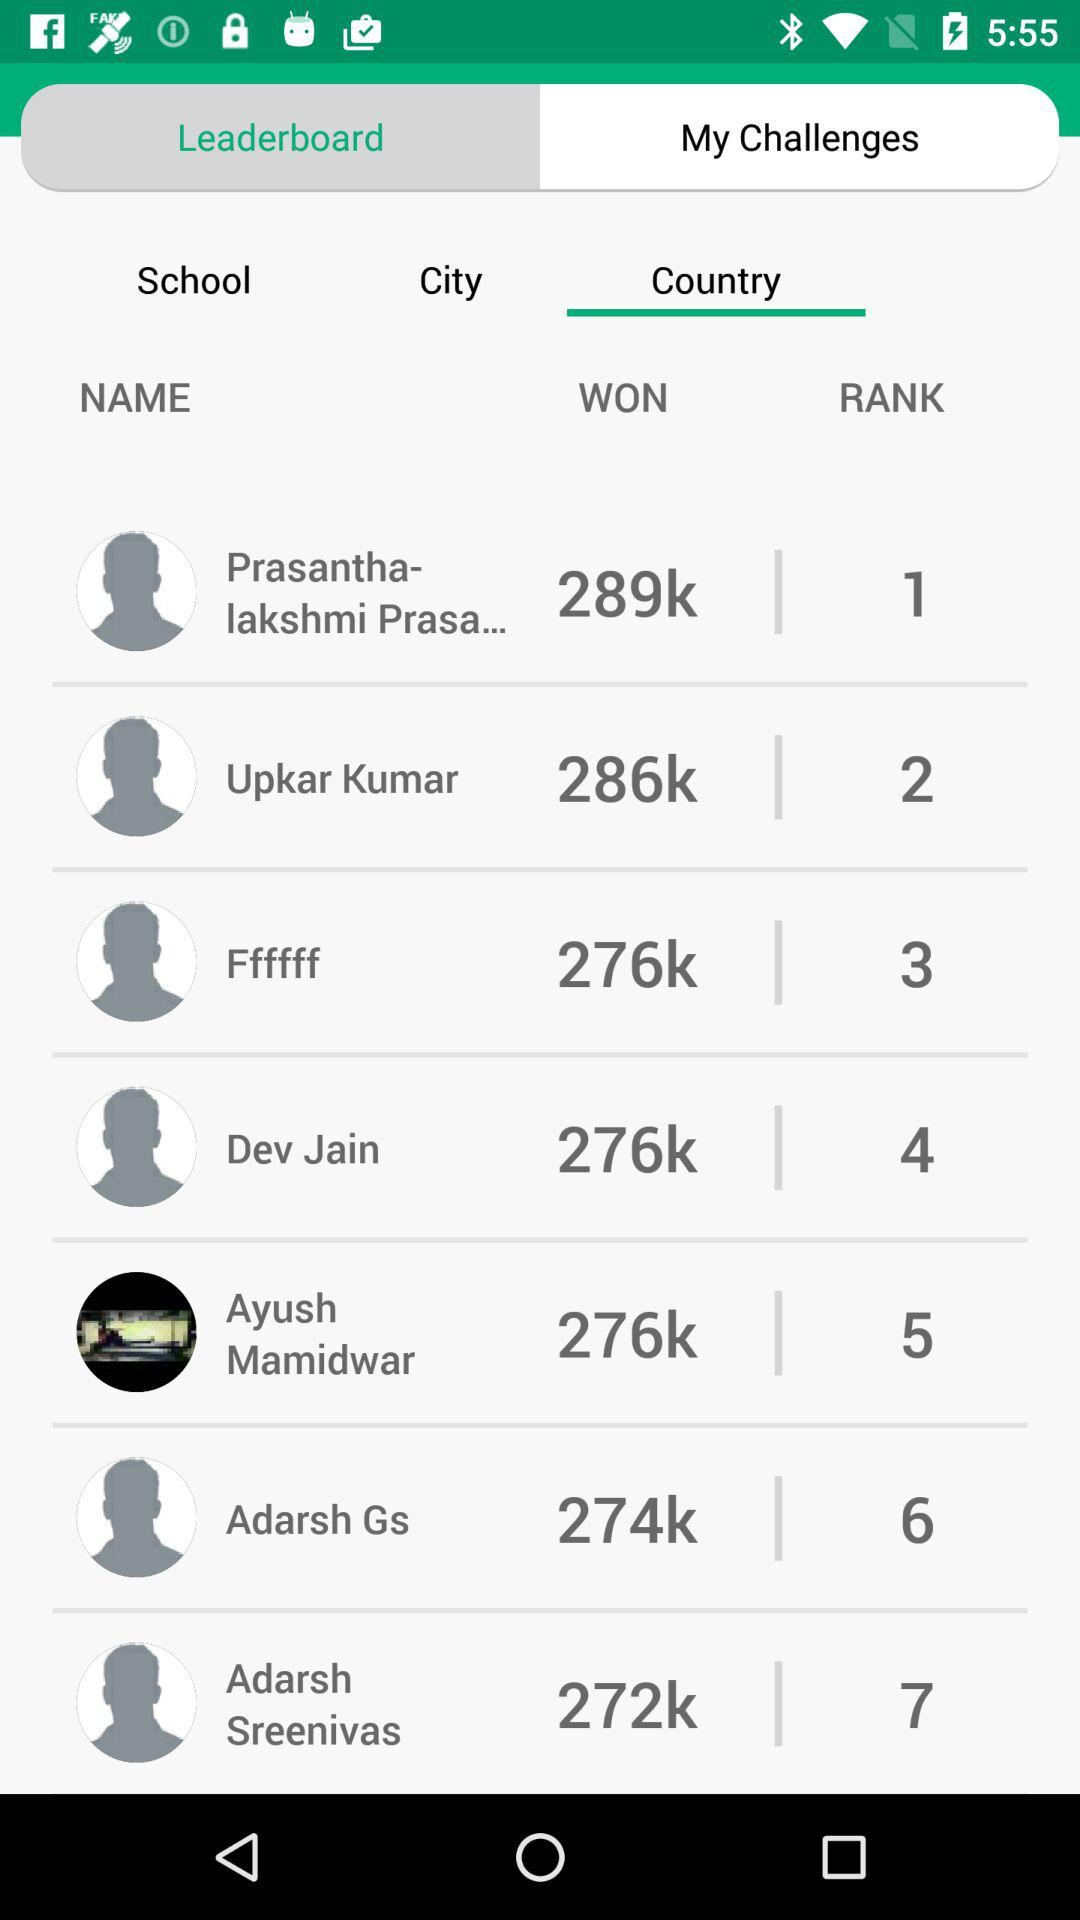What is the rank of "Prasantha-lakshmi Prasa..."? The rank is the first. 